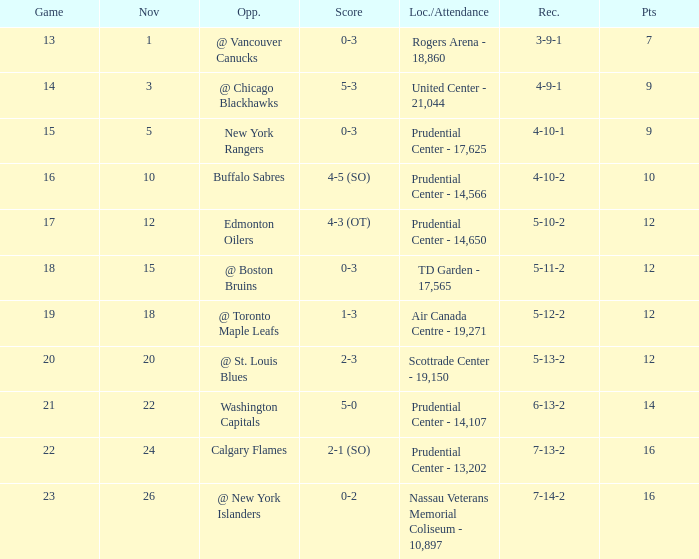What is the record for score 1-3? 5-12-2. 